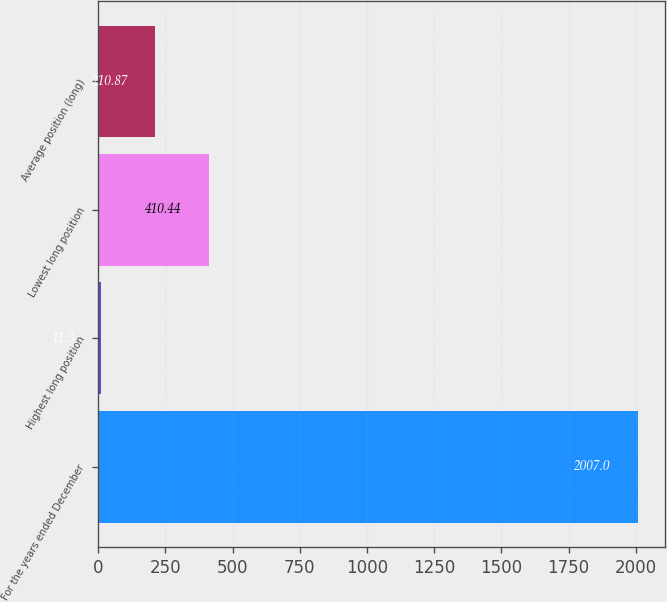Convert chart to OTSL. <chart><loc_0><loc_0><loc_500><loc_500><bar_chart><fcel>For the years ended December<fcel>Highest long position<fcel>Lowest long position<fcel>Average position (long)<nl><fcel>2007<fcel>11.3<fcel>410.44<fcel>210.87<nl></chart> 